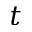<formula> <loc_0><loc_0><loc_500><loc_500>t</formula> 